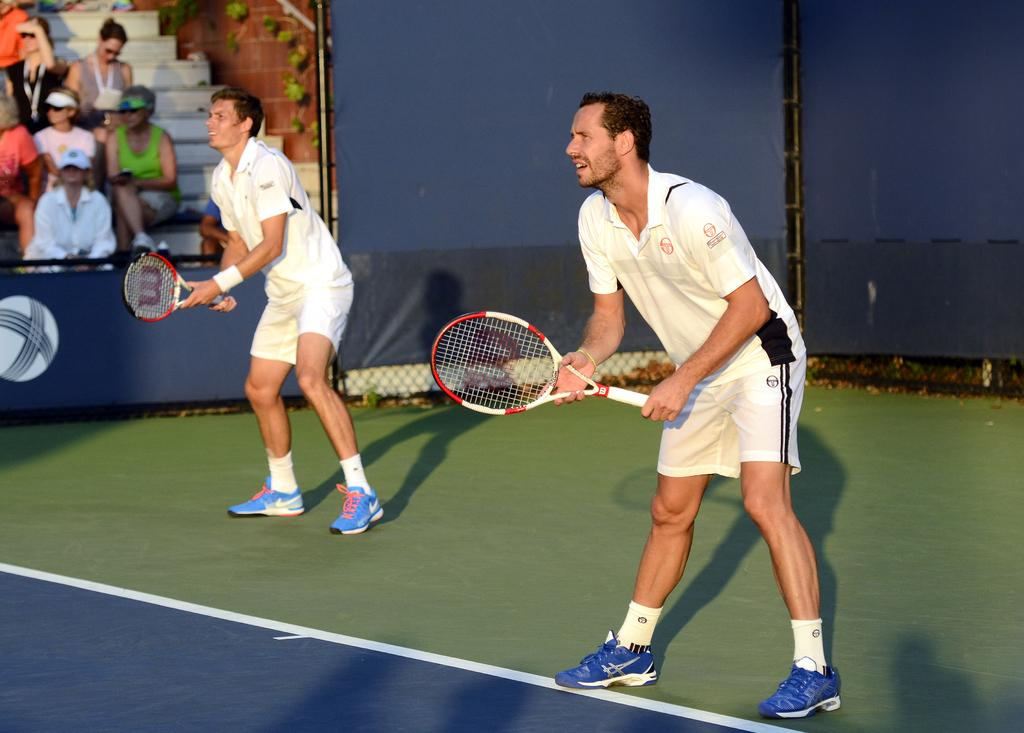How many people are standing in the image? There are two persons standing in the image. What are the two persons holding in their hands? The two persons are holding rackets in their hands. Can you describe the group of people sitting in the image? There is a group of persons sitting on a staircase. What type of glue is being used by the achiever in the image? There is no achiever or glue present in the image. 